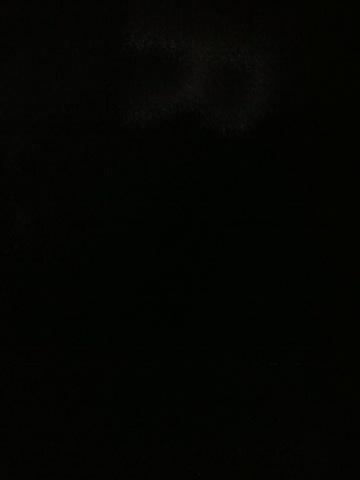Imagine if a creature lived in this darkness. Describe what it might be like! In the enveloping darkness of this image, one could imagine a mysterious creature that thrives in the shadows. This creature might have heightened senses to navigate and hunt without light, perhaps possessing bioluminescent features to communicate or attract prey. Its skin could be a deep, rich black to blend seamlessly with its environment, and it might move silently, an almost ghostly presence in the pitch-black world. 